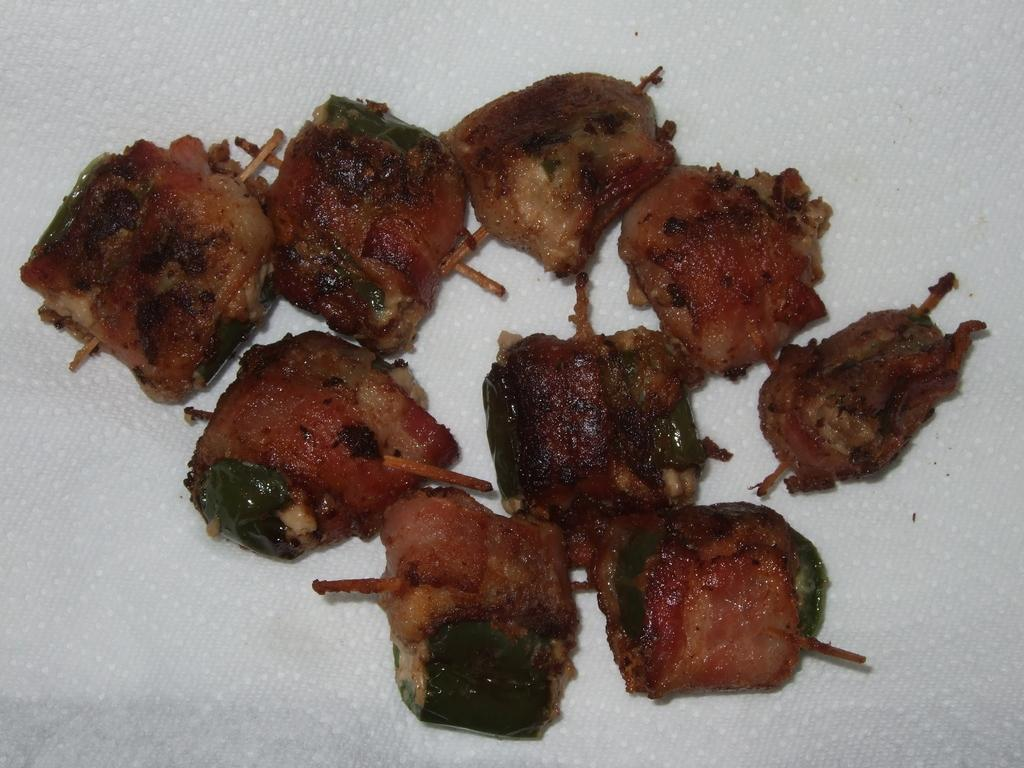What is present in the image? There is food in the image. How is the food presented? The food is on tissue paper. What can be seen sticking out of the food? The food has sticks in it. What type of advertisement can be seen on the food in the image? There is no advertisement present on the food in the image. What selection of food is available in the image? The image only shows one type of food, which is the food with sticks in it. 